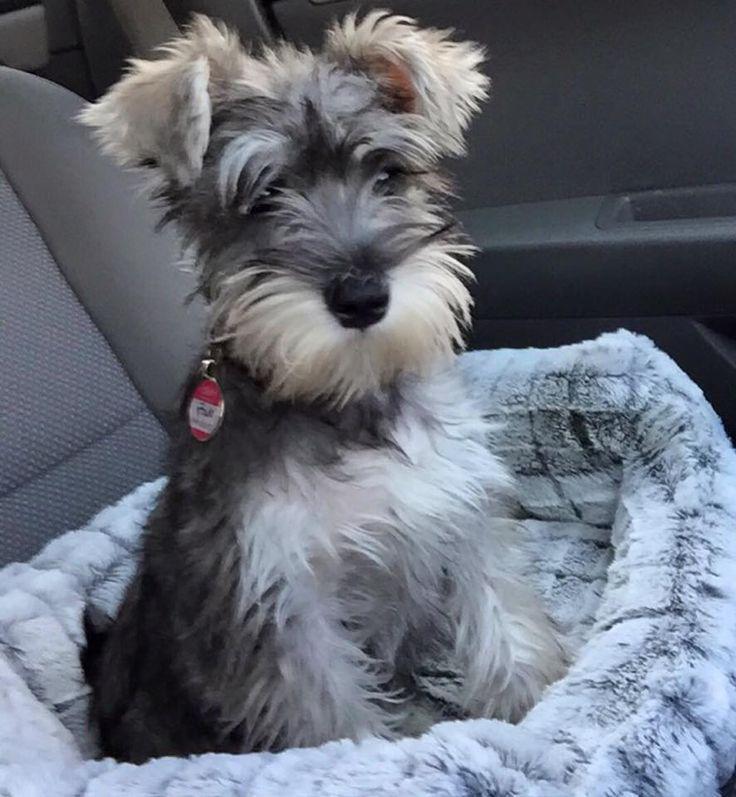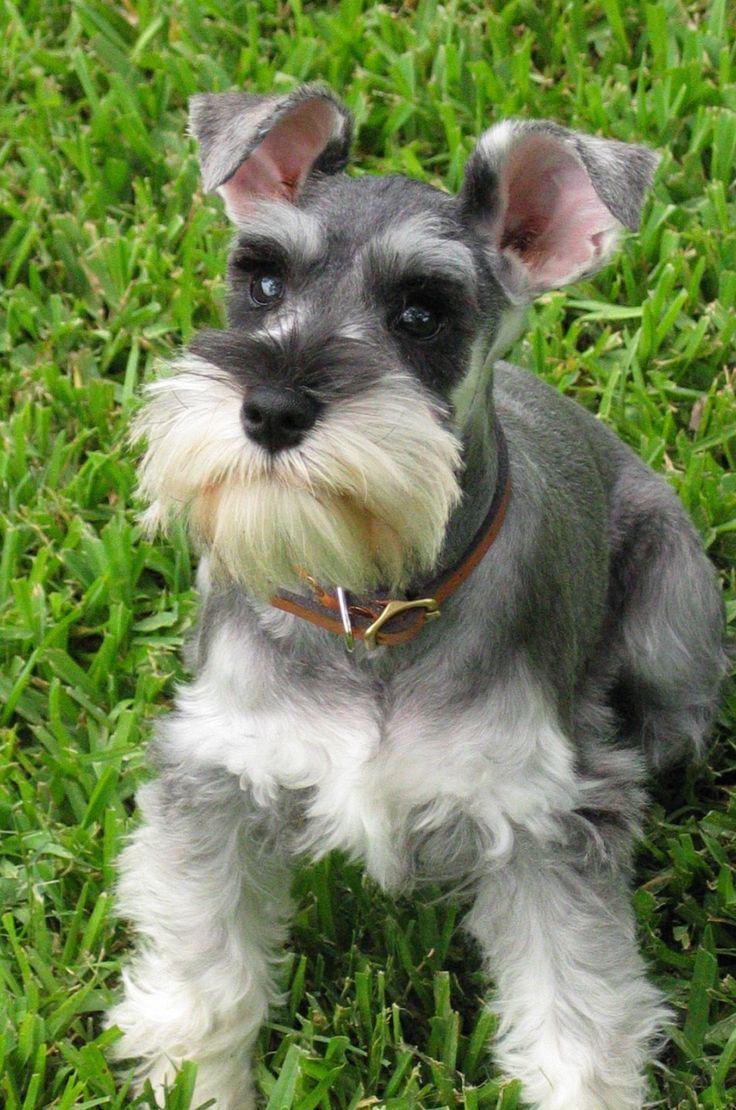The first image is the image on the left, the second image is the image on the right. Examine the images to the left and right. Is the description "The dog in the right image is sitting on grass looking towards the right." accurate? Answer yes or no. No. The first image is the image on the left, the second image is the image on the right. Considering the images on both sides, is "At least one of the dogs is not outside." valid? Answer yes or no. Yes. The first image is the image on the left, the second image is the image on the right. Given the left and right images, does the statement "At least one dog has no visible collar on." hold true? Answer yes or no. No. 